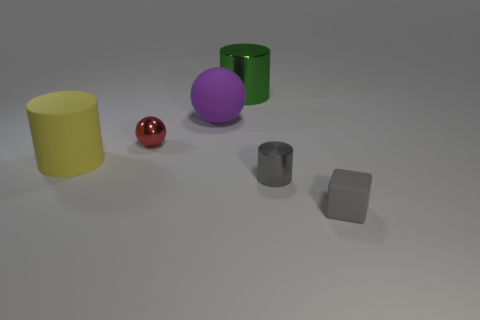Subtract 1 cylinders. How many cylinders are left? 2 Add 3 purple rubber cylinders. How many objects exist? 9 Subtract all blocks. How many objects are left? 5 Subtract 0 blue spheres. How many objects are left? 6 Subtract all big purple cylinders. Subtract all tiny metallic objects. How many objects are left? 4 Add 2 big purple rubber objects. How many big purple rubber objects are left? 3 Add 5 matte things. How many matte things exist? 8 